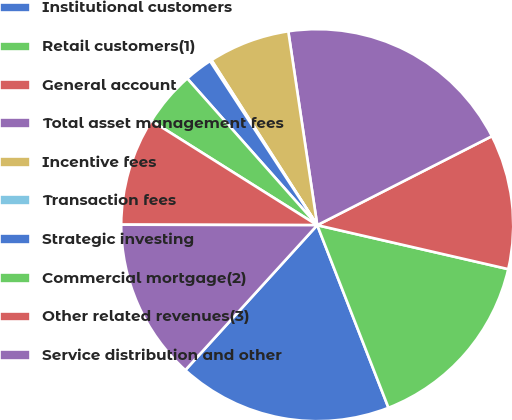<chart> <loc_0><loc_0><loc_500><loc_500><pie_chart><fcel>Institutional customers<fcel>Retail customers(1)<fcel>General account<fcel>Total asset management fees<fcel>Incentive fees<fcel>Transaction fees<fcel>Strategic investing<fcel>Commercial mortgage(2)<fcel>Other related revenues(3)<fcel>Service distribution and other<nl><fcel>17.67%<fcel>15.48%<fcel>11.1%<fcel>19.86%<fcel>6.71%<fcel>0.14%<fcel>2.33%<fcel>4.52%<fcel>8.9%<fcel>13.29%<nl></chart> 